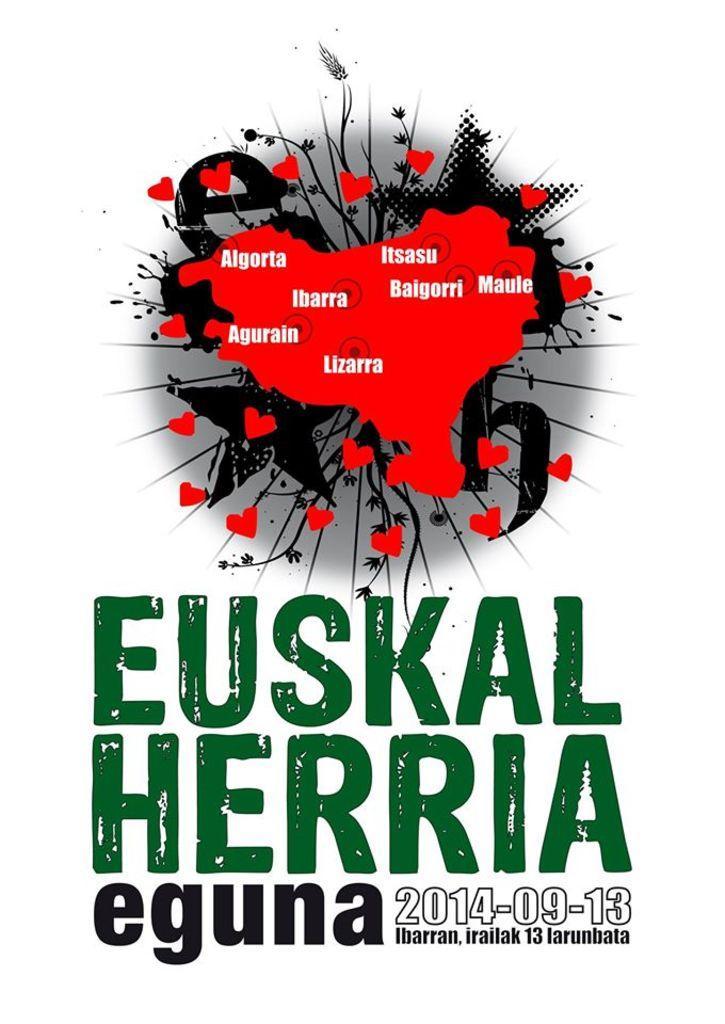Can you describe this image briefly? In this image there is poster having some text in green and black color. Top of it there is a map having some location names on it. Background is white in color. 